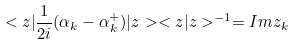<formula> <loc_0><loc_0><loc_500><loc_500>< z | \frac { 1 } { 2 i } ( \alpha _ { k } - \alpha _ { k } ^ { + } ) | z > < z | z > ^ { - 1 } = I m z _ { k }</formula> 